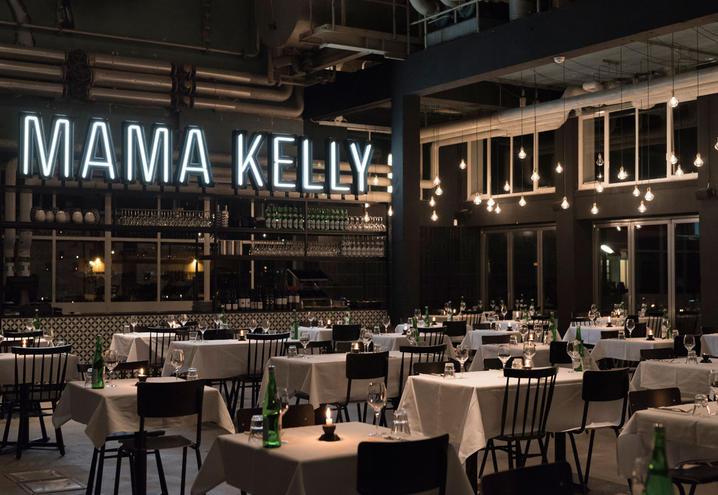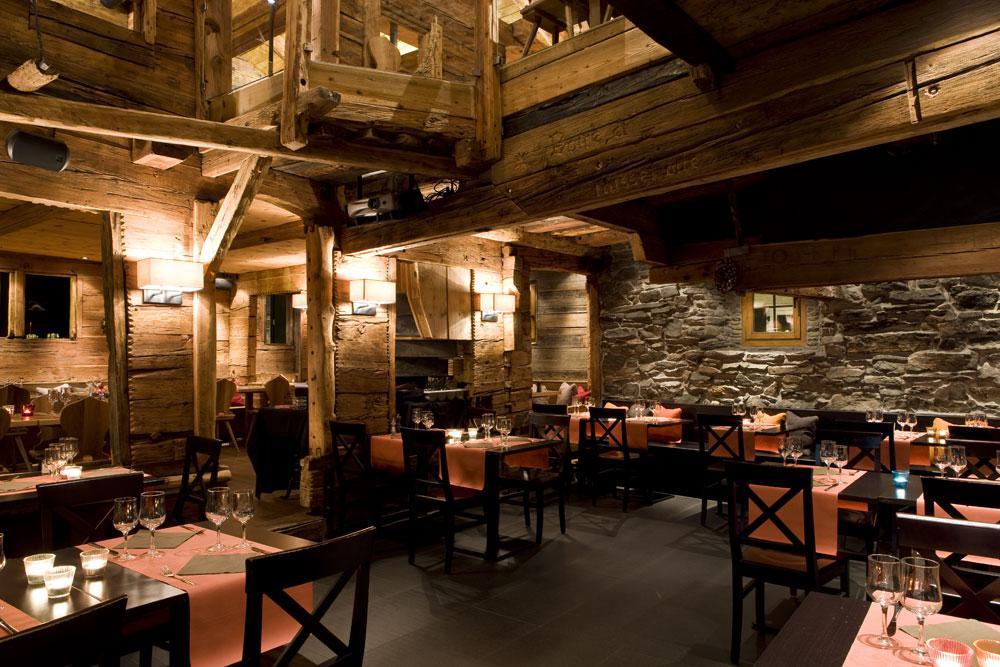The first image is the image on the left, the second image is the image on the right. Evaluate the accuracy of this statement regarding the images: "The tables in the right image are long bench style tables.". Is it true? Answer yes or no. No. The first image is the image on the left, the second image is the image on the right. Evaluate the accuracy of this statement regarding the images: "There is at least four white cloth tables.". Is it true? Answer yes or no. Yes. 